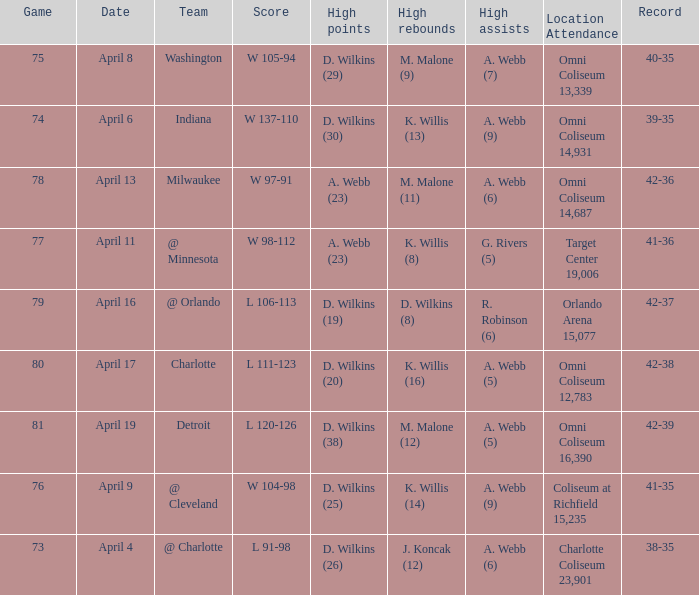What was the date of the game when g. rivers (5) had the  high assists? April 11. 